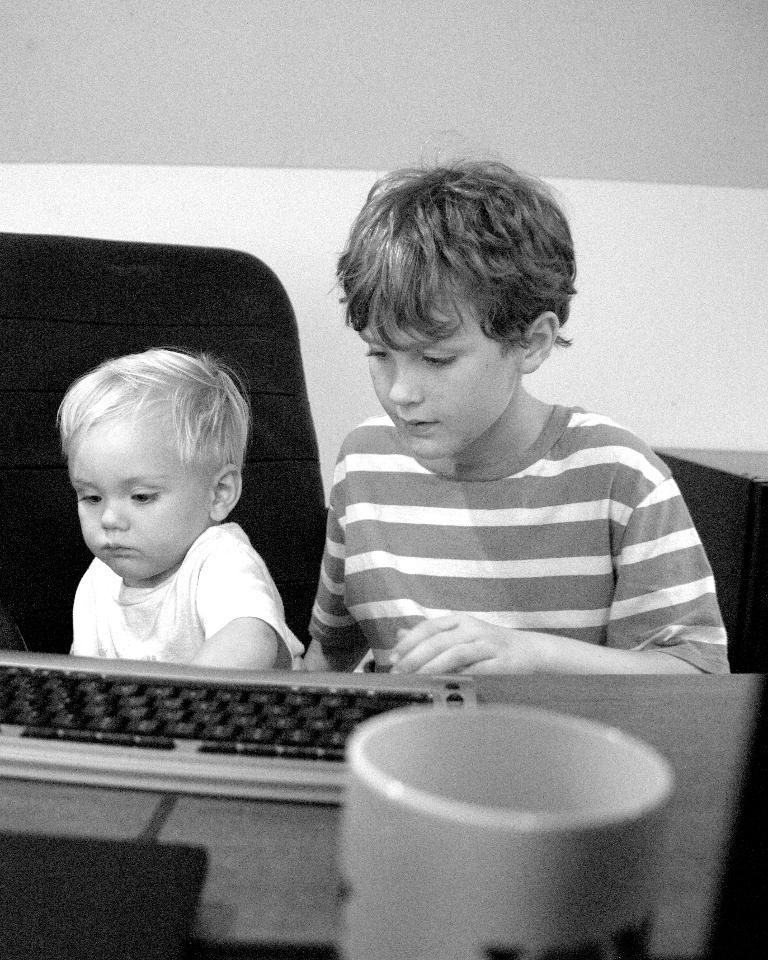What is the boy in the image doing? The boy is sitting on a chair in the image. How many boys are in the image? There are two boys in the image. What object is on the table in the image? There is a keyboard and a cup on the table in the image. What type of cloth is draped over the boy's toes in the image? There is no cloth draped over the boy's toes in the image, as the provided facts do not mention any cloth or toes. 